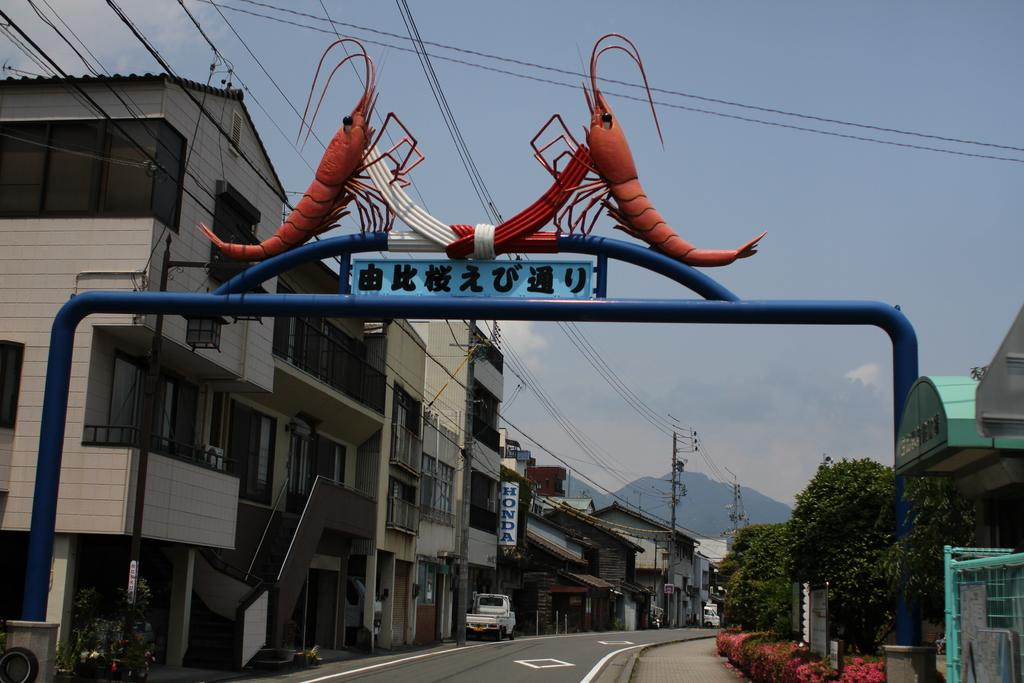What structure is located in the middle of the image? There is an arch in the middle of the image. What can be seen in the background of the image? There are buildings, poles, trees, vehicles, hills, and clouds visible in the background of the image. Where is the boy sitting on the throne in the image? There is no boy or throne present in the image. What type of stitch is used to create the pattern on the arch in the image? The image does not provide information about the stitch used to create the pattern on the arch, as it is a photograph and not a textile. 